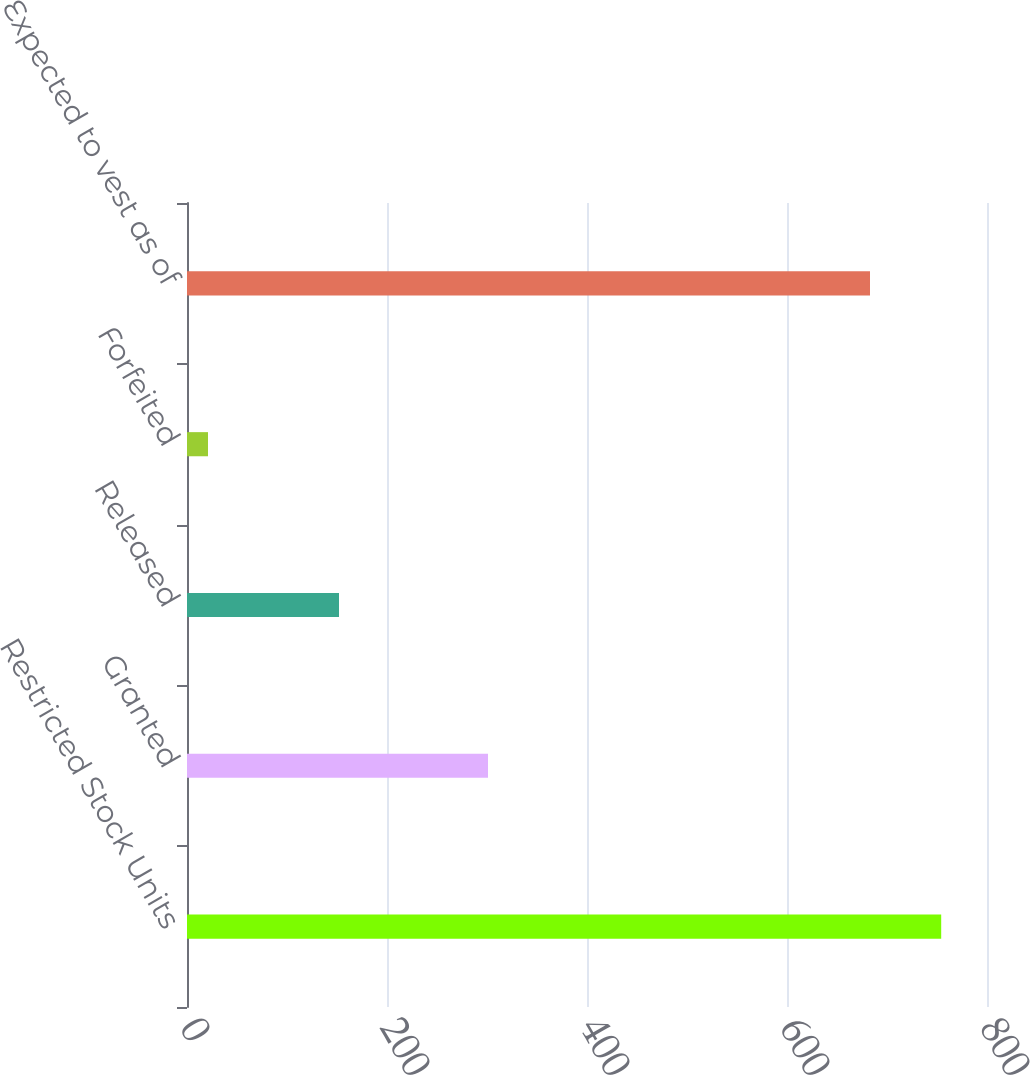Convert chart to OTSL. <chart><loc_0><loc_0><loc_500><loc_500><bar_chart><fcel>Restricted Stock Units<fcel>Granted<fcel>Released<fcel>Forfeited<fcel>Expected to vest as of<nl><fcel>754.2<fcel>301<fcel>152<fcel>21<fcel>683<nl></chart> 